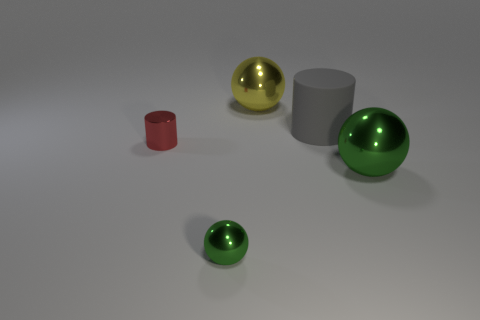Add 1 yellow things. How many objects exist? 6 Subtract all green spheres. How many spheres are left? 1 Subtract all large spheres. How many spheres are left? 1 Subtract 2 cylinders. How many cylinders are left? 0 Add 1 spheres. How many spheres exist? 4 Subtract 0 green cubes. How many objects are left? 5 Subtract all cylinders. How many objects are left? 3 Subtract all gray cylinders. Subtract all red spheres. How many cylinders are left? 1 Subtract all red balls. How many red cylinders are left? 1 Subtract all big shiny objects. Subtract all big gray matte things. How many objects are left? 2 